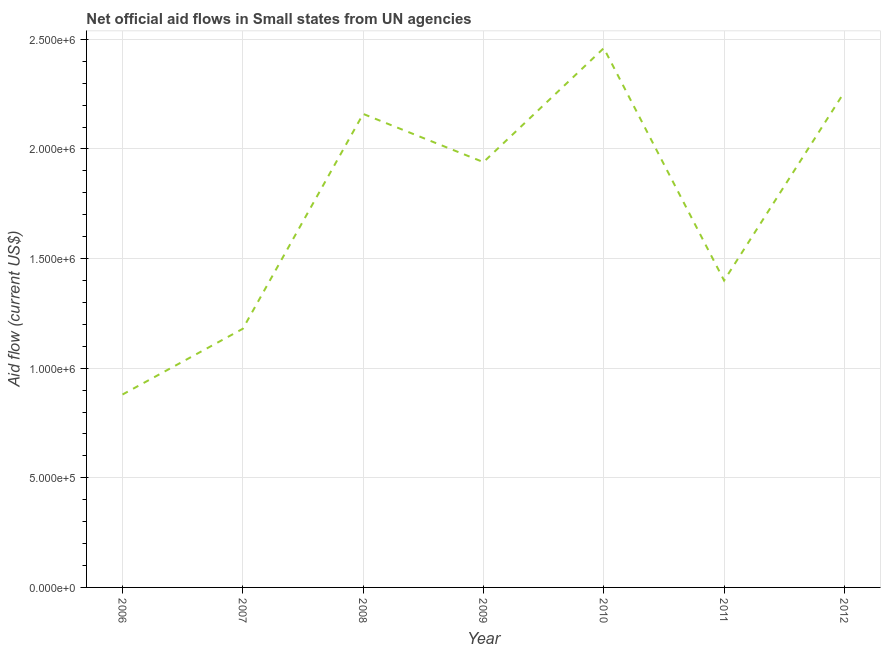What is the net official flows from un agencies in 2009?
Provide a succinct answer. 1.94e+06. Across all years, what is the maximum net official flows from un agencies?
Your answer should be very brief. 2.46e+06. Across all years, what is the minimum net official flows from un agencies?
Provide a short and direct response. 8.80e+05. In which year was the net official flows from un agencies maximum?
Your answer should be very brief. 2010. What is the sum of the net official flows from un agencies?
Your answer should be compact. 1.23e+07. What is the difference between the net official flows from un agencies in 2009 and 2010?
Your answer should be compact. -5.20e+05. What is the average net official flows from un agencies per year?
Your answer should be very brief. 1.75e+06. What is the median net official flows from un agencies?
Offer a terse response. 1.94e+06. In how many years, is the net official flows from un agencies greater than 500000 US$?
Give a very brief answer. 7. Do a majority of the years between 2006 and 2012 (inclusive) have net official flows from un agencies greater than 700000 US$?
Your answer should be compact. Yes. What is the ratio of the net official flows from un agencies in 2010 to that in 2011?
Your answer should be compact. 1.76. Is the difference between the net official flows from un agencies in 2009 and 2011 greater than the difference between any two years?
Give a very brief answer. No. Is the sum of the net official flows from un agencies in 2006 and 2010 greater than the maximum net official flows from un agencies across all years?
Make the answer very short. Yes. What is the difference between the highest and the lowest net official flows from un agencies?
Offer a very short reply. 1.58e+06. In how many years, is the net official flows from un agencies greater than the average net official flows from un agencies taken over all years?
Offer a very short reply. 4. Does the net official flows from un agencies monotonically increase over the years?
Offer a terse response. No. How many lines are there?
Make the answer very short. 1. What is the difference between two consecutive major ticks on the Y-axis?
Offer a terse response. 5.00e+05. Are the values on the major ticks of Y-axis written in scientific E-notation?
Keep it short and to the point. Yes. What is the title of the graph?
Make the answer very short. Net official aid flows in Small states from UN agencies. What is the label or title of the X-axis?
Provide a succinct answer. Year. What is the label or title of the Y-axis?
Offer a very short reply. Aid flow (current US$). What is the Aid flow (current US$) of 2006?
Make the answer very short. 8.80e+05. What is the Aid flow (current US$) of 2007?
Offer a very short reply. 1.18e+06. What is the Aid flow (current US$) in 2008?
Offer a very short reply. 2.16e+06. What is the Aid flow (current US$) in 2009?
Your answer should be very brief. 1.94e+06. What is the Aid flow (current US$) of 2010?
Your answer should be very brief. 2.46e+06. What is the Aid flow (current US$) of 2011?
Give a very brief answer. 1.40e+06. What is the Aid flow (current US$) of 2012?
Offer a very short reply. 2.26e+06. What is the difference between the Aid flow (current US$) in 2006 and 2007?
Make the answer very short. -3.00e+05. What is the difference between the Aid flow (current US$) in 2006 and 2008?
Provide a succinct answer. -1.28e+06. What is the difference between the Aid flow (current US$) in 2006 and 2009?
Your response must be concise. -1.06e+06. What is the difference between the Aid flow (current US$) in 2006 and 2010?
Provide a succinct answer. -1.58e+06. What is the difference between the Aid flow (current US$) in 2006 and 2011?
Provide a succinct answer. -5.20e+05. What is the difference between the Aid flow (current US$) in 2006 and 2012?
Ensure brevity in your answer.  -1.38e+06. What is the difference between the Aid flow (current US$) in 2007 and 2008?
Give a very brief answer. -9.80e+05. What is the difference between the Aid flow (current US$) in 2007 and 2009?
Keep it short and to the point. -7.60e+05. What is the difference between the Aid flow (current US$) in 2007 and 2010?
Keep it short and to the point. -1.28e+06. What is the difference between the Aid flow (current US$) in 2007 and 2012?
Offer a terse response. -1.08e+06. What is the difference between the Aid flow (current US$) in 2008 and 2009?
Provide a short and direct response. 2.20e+05. What is the difference between the Aid flow (current US$) in 2008 and 2011?
Your response must be concise. 7.60e+05. What is the difference between the Aid flow (current US$) in 2008 and 2012?
Ensure brevity in your answer.  -1.00e+05. What is the difference between the Aid flow (current US$) in 2009 and 2010?
Your answer should be very brief. -5.20e+05. What is the difference between the Aid flow (current US$) in 2009 and 2011?
Your response must be concise. 5.40e+05. What is the difference between the Aid flow (current US$) in 2009 and 2012?
Your answer should be compact. -3.20e+05. What is the difference between the Aid flow (current US$) in 2010 and 2011?
Provide a succinct answer. 1.06e+06. What is the difference between the Aid flow (current US$) in 2011 and 2012?
Give a very brief answer. -8.60e+05. What is the ratio of the Aid flow (current US$) in 2006 to that in 2007?
Ensure brevity in your answer.  0.75. What is the ratio of the Aid flow (current US$) in 2006 to that in 2008?
Give a very brief answer. 0.41. What is the ratio of the Aid flow (current US$) in 2006 to that in 2009?
Ensure brevity in your answer.  0.45. What is the ratio of the Aid flow (current US$) in 2006 to that in 2010?
Provide a succinct answer. 0.36. What is the ratio of the Aid flow (current US$) in 2006 to that in 2011?
Offer a terse response. 0.63. What is the ratio of the Aid flow (current US$) in 2006 to that in 2012?
Offer a very short reply. 0.39. What is the ratio of the Aid flow (current US$) in 2007 to that in 2008?
Your response must be concise. 0.55. What is the ratio of the Aid flow (current US$) in 2007 to that in 2009?
Provide a short and direct response. 0.61. What is the ratio of the Aid flow (current US$) in 2007 to that in 2010?
Give a very brief answer. 0.48. What is the ratio of the Aid flow (current US$) in 2007 to that in 2011?
Your answer should be compact. 0.84. What is the ratio of the Aid flow (current US$) in 2007 to that in 2012?
Provide a succinct answer. 0.52. What is the ratio of the Aid flow (current US$) in 2008 to that in 2009?
Give a very brief answer. 1.11. What is the ratio of the Aid flow (current US$) in 2008 to that in 2010?
Provide a succinct answer. 0.88. What is the ratio of the Aid flow (current US$) in 2008 to that in 2011?
Give a very brief answer. 1.54. What is the ratio of the Aid flow (current US$) in 2008 to that in 2012?
Offer a terse response. 0.96. What is the ratio of the Aid flow (current US$) in 2009 to that in 2010?
Offer a terse response. 0.79. What is the ratio of the Aid flow (current US$) in 2009 to that in 2011?
Provide a short and direct response. 1.39. What is the ratio of the Aid flow (current US$) in 2009 to that in 2012?
Give a very brief answer. 0.86. What is the ratio of the Aid flow (current US$) in 2010 to that in 2011?
Your response must be concise. 1.76. What is the ratio of the Aid flow (current US$) in 2010 to that in 2012?
Give a very brief answer. 1.09. What is the ratio of the Aid flow (current US$) in 2011 to that in 2012?
Provide a short and direct response. 0.62. 